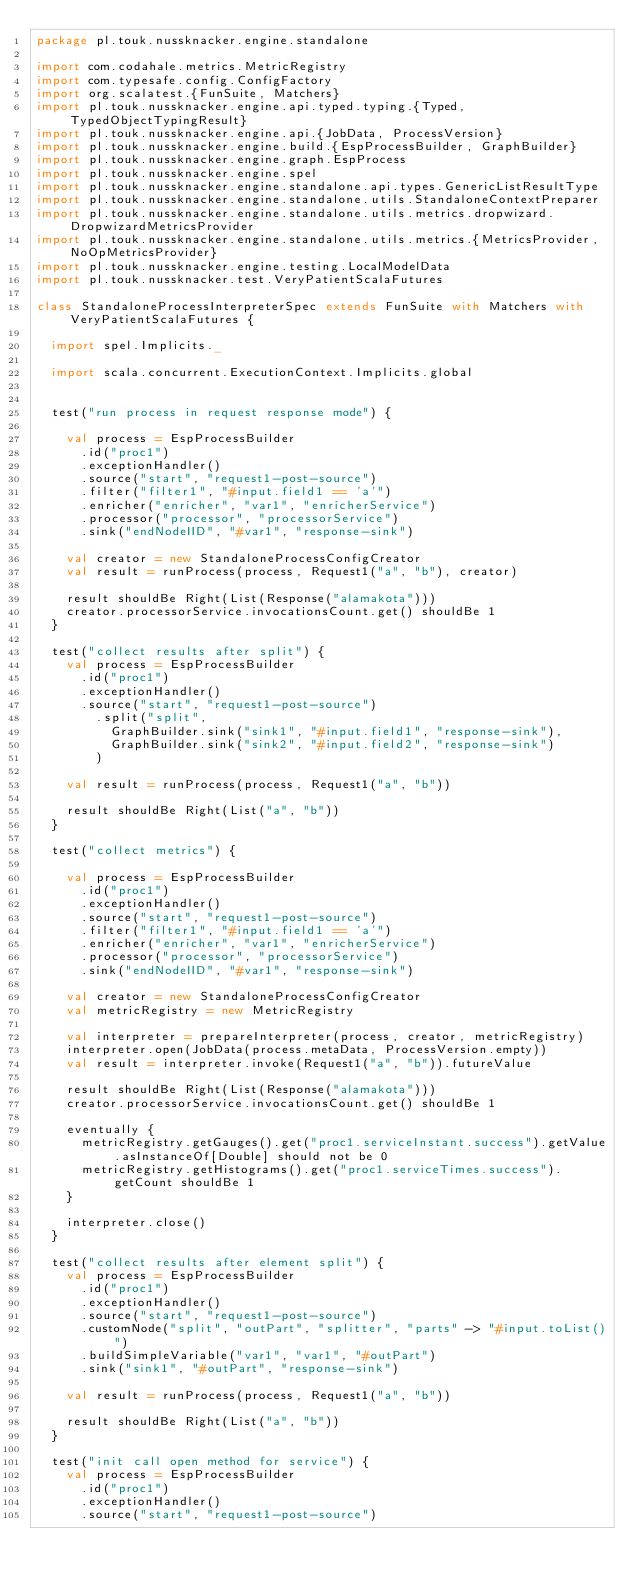Convert code to text. <code><loc_0><loc_0><loc_500><loc_500><_Scala_>package pl.touk.nussknacker.engine.standalone

import com.codahale.metrics.MetricRegistry
import com.typesafe.config.ConfigFactory
import org.scalatest.{FunSuite, Matchers}
import pl.touk.nussknacker.engine.api.typed.typing.{Typed, TypedObjectTypingResult}
import pl.touk.nussknacker.engine.api.{JobData, ProcessVersion}
import pl.touk.nussknacker.engine.build.{EspProcessBuilder, GraphBuilder}
import pl.touk.nussknacker.engine.graph.EspProcess
import pl.touk.nussknacker.engine.spel
import pl.touk.nussknacker.engine.standalone.api.types.GenericListResultType
import pl.touk.nussknacker.engine.standalone.utils.StandaloneContextPreparer
import pl.touk.nussknacker.engine.standalone.utils.metrics.dropwizard.DropwizardMetricsProvider
import pl.touk.nussknacker.engine.standalone.utils.metrics.{MetricsProvider, NoOpMetricsProvider}
import pl.touk.nussknacker.engine.testing.LocalModelData
import pl.touk.nussknacker.test.VeryPatientScalaFutures

class StandaloneProcessInterpreterSpec extends FunSuite with Matchers with VeryPatientScalaFutures {

  import spel.Implicits._

  import scala.concurrent.ExecutionContext.Implicits.global


  test("run process in request response mode") {

    val process = EspProcessBuilder
      .id("proc1")
      .exceptionHandler()
      .source("start", "request1-post-source")
      .filter("filter1", "#input.field1 == 'a'")
      .enricher("enricher", "var1", "enricherService")
      .processor("processor", "processorService")
      .sink("endNodeIID", "#var1", "response-sink")

    val creator = new StandaloneProcessConfigCreator
    val result = runProcess(process, Request1("a", "b"), creator)

    result shouldBe Right(List(Response("alamakota")))
    creator.processorService.invocationsCount.get() shouldBe 1
  }

  test("collect results after split") {
    val process = EspProcessBuilder
      .id("proc1")
      .exceptionHandler()
      .source("start", "request1-post-source")
        .split("split",
          GraphBuilder.sink("sink1", "#input.field1", "response-sink"),
          GraphBuilder.sink("sink2", "#input.field2", "response-sink")
        )

    val result = runProcess(process, Request1("a", "b"))

    result shouldBe Right(List("a", "b"))
  }

  test("collect metrics") {

    val process = EspProcessBuilder
      .id("proc1")
      .exceptionHandler()
      .source("start", "request1-post-source")
      .filter("filter1", "#input.field1 == 'a'")
      .enricher("enricher", "var1", "enricherService")
      .processor("processor", "processorService")
      .sink("endNodeIID", "#var1", "response-sink")

    val creator = new StandaloneProcessConfigCreator
    val metricRegistry = new MetricRegistry

    val interpreter = prepareInterpreter(process, creator, metricRegistry)
    interpreter.open(JobData(process.metaData, ProcessVersion.empty))
    val result = interpreter.invoke(Request1("a", "b")).futureValue

    result shouldBe Right(List(Response("alamakota")))
    creator.processorService.invocationsCount.get() shouldBe 1

    eventually {
      metricRegistry.getGauges().get("proc1.serviceInstant.success").getValue.asInstanceOf[Double] should not be 0
      metricRegistry.getHistograms().get("proc1.serviceTimes.success").getCount shouldBe 1
    }

    interpreter.close()
  }

  test("collect results after element split") {
    val process = EspProcessBuilder
      .id("proc1")
      .exceptionHandler()
      .source("start", "request1-post-source")
      .customNode("split", "outPart", "splitter", "parts" -> "#input.toList()")
      .buildSimpleVariable("var1", "var1", "#outPart")
      .sink("sink1", "#outPart", "response-sink")

    val result = runProcess(process, Request1("a", "b"))

    result shouldBe Right(List("a", "b"))
  }

  test("init call open method for service") {
    val process = EspProcessBuilder
      .id("proc1")
      .exceptionHandler()
      .source("start", "request1-post-source")</code> 